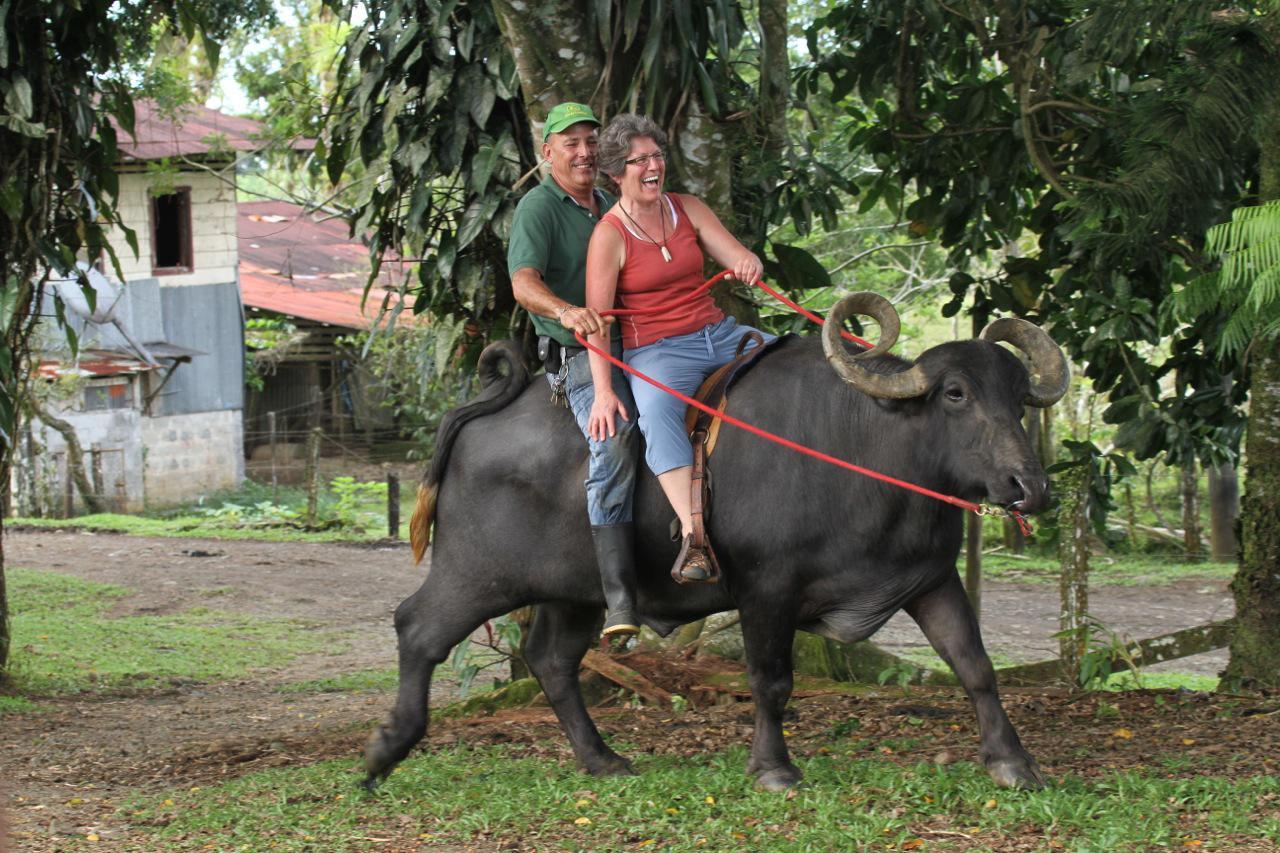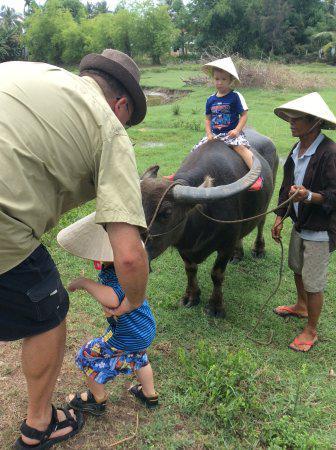The first image is the image on the left, the second image is the image on the right. Evaluate the accuracy of this statement regarding the images: "There are exactly two people riding on animals.". Is it true? Answer yes or no. No. The first image is the image on the left, the second image is the image on the right. Given the left and right images, does the statement "There is exactly one person riding a water buffalo in each image." hold true? Answer yes or no. No. 